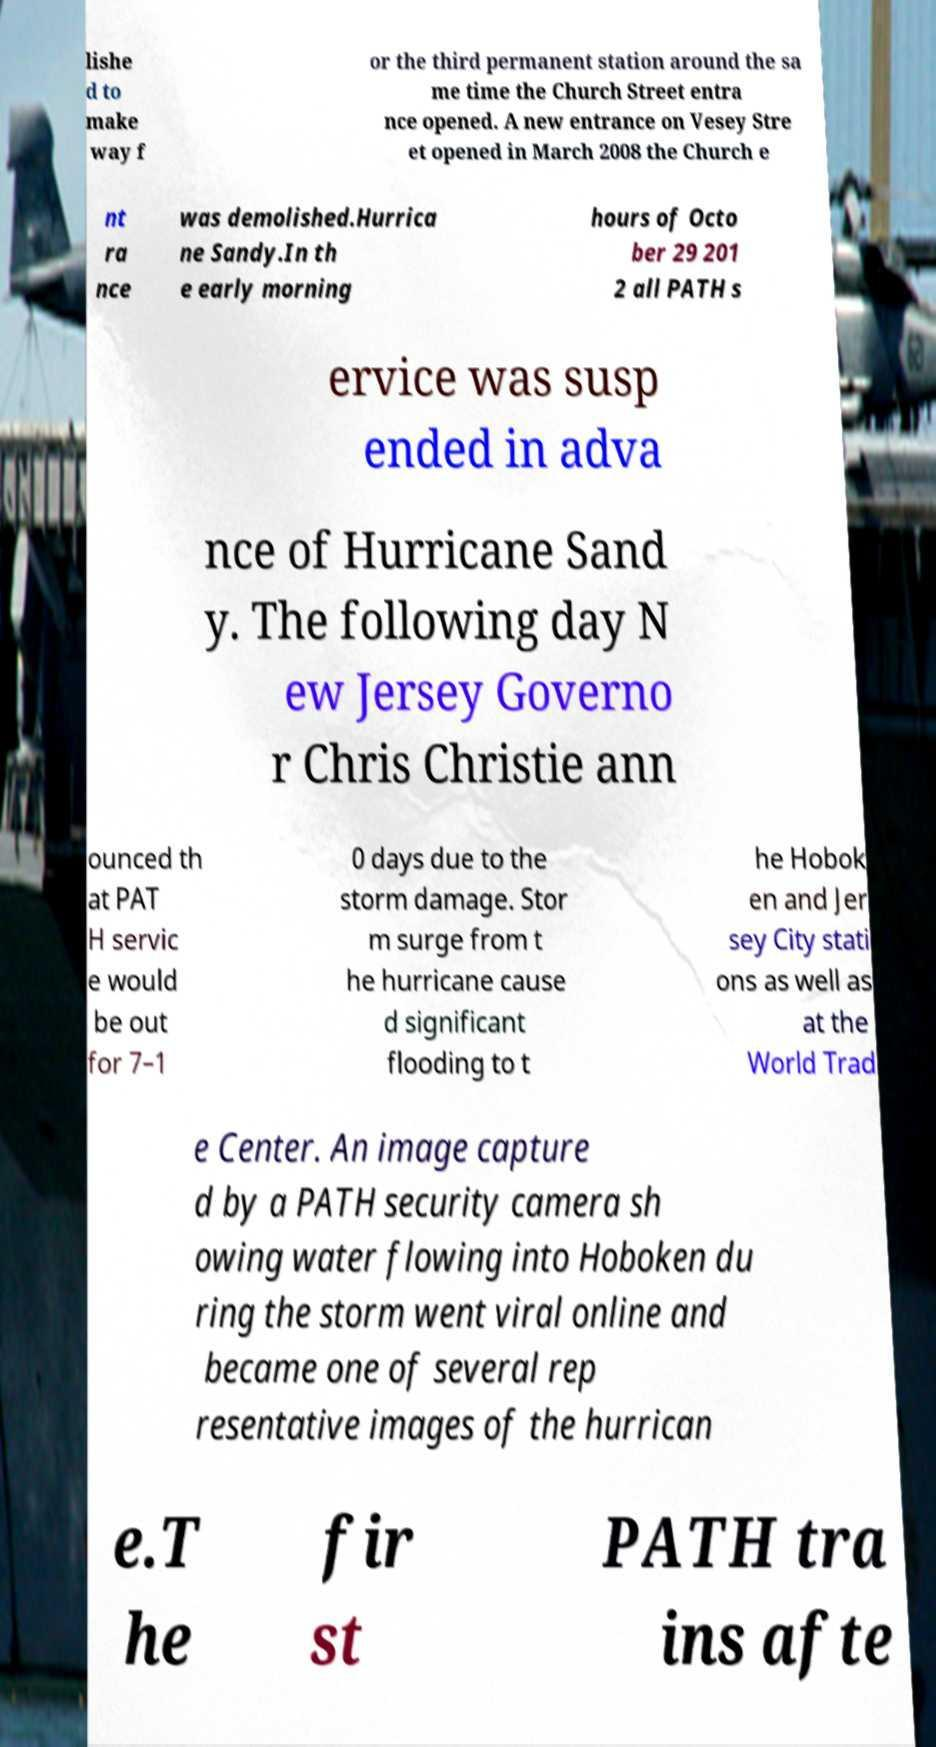For documentation purposes, I need the text within this image transcribed. Could you provide that? lishe d to make way f or the third permanent station around the sa me time the Church Street entra nce opened. A new entrance on Vesey Stre et opened in March 2008 the Church e nt ra nce was demolished.Hurrica ne Sandy.In th e early morning hours of Octo ber 29 201 2 all PATH s ervice was susp ended in adva nce of Hurricane Sand y. The following day N ew Jersey Governo r Chris Christie ann ounced th at PAT H servic e would be out for 7–1 0 days due to the storm damage. Stor m surge from t he hurricane cause d significant flooding to t he Hobok en and Jer sey City stati ons as well as at the World Trad e Center. An image capture d by a PATH security camera sh owing water flowing into Hoboken du ring the storm went viral online and became one of several rep resentative images of the hurrican e.T he fir st PATH tra ins afte 